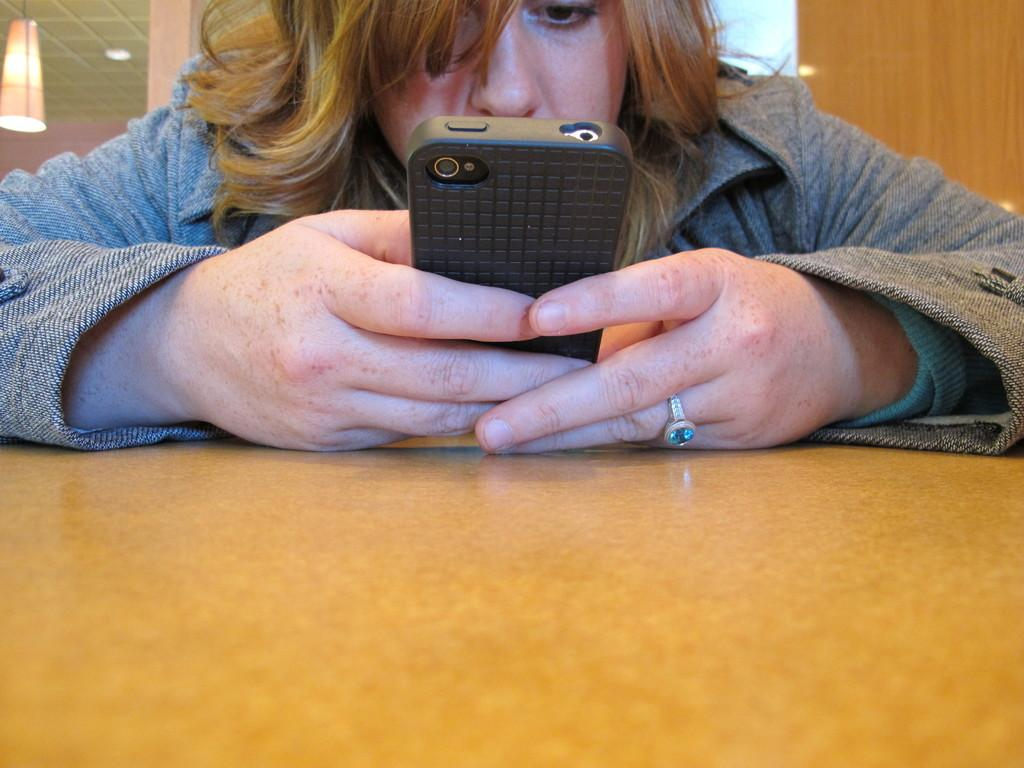Who is present in the image? There is a woman in the image. What is the woman holding? The woman is holding a mobile. Where is the mobile located? The mobile is on a table. What can be seen in the background of the image? There is a wooden wall and a light in the background of the image. What type of berry is hanging from the wooden wall in the image? There is no berry present in the image; the wooden wall is a background element. 